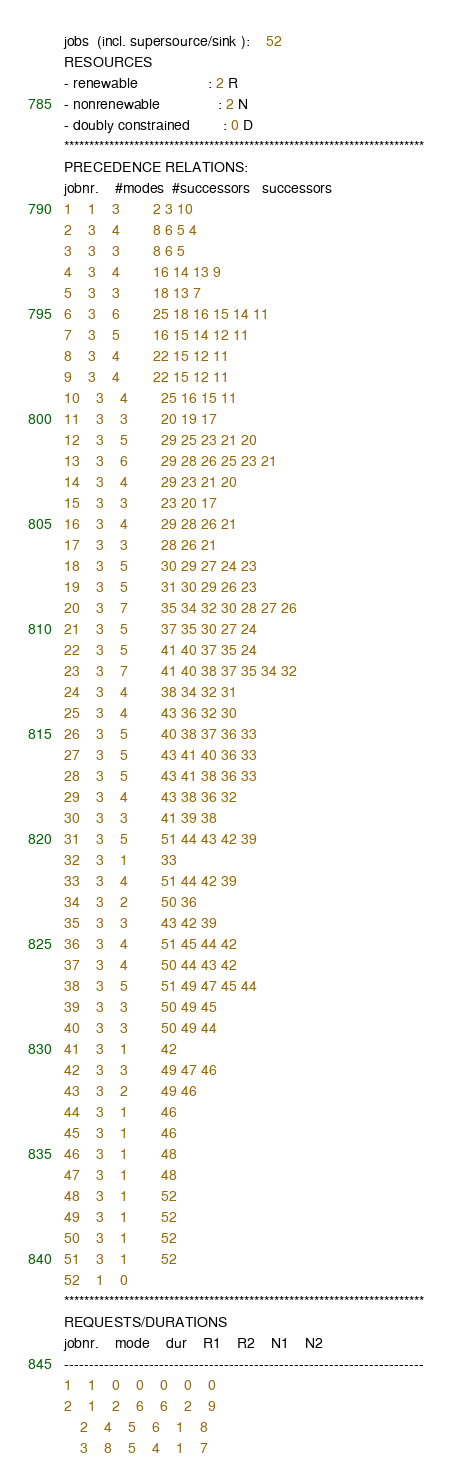<code> <loc_0><loc_0><loc_500><loc_500><_ObjectiveC_>jobs  (incl. supersource/sink ):	52
RESOURCES
- renewable                 : 2 R
- nonrenewable              : 2 N
- doubly constrained        : 0 D
************************************************************************
PRECEDENCE RELATIONS:
jobnr.    #modes  #successors   successors
1	1	3		2 3 10 
2	3	4		8 6 5 4 
3	3	3		8 6 5 
4	3	4		16 14 13 9 
5	3	3		18 13 7 
6	3	6		25 18 16 15 14 11 
7	3	5		16 15 14 12 11 
8	3	4		22 15 12 11 
9	3	4		22 15 12 11 
10	3	4		25 16 15 11 
11	3	3		20 19 17 
12	3	5		29 25 23 21 20 
13	3	6		29 28 26 25 23 21 
14	3	4		29 23 21 20 
15	3	3		23 20 17 
16	3	4		29 28 26 21 
17	3	3		28 26 21 
18	3	5		30 29 27 24 23 
19	3	5		31 30 29 26 23 
20	3	7		35 34 32 30 28 27 26 
21	3	5		37 35 30 27 24 
22	3	5		41 40 37 35 24 
23	3	7		41 40 38 37 35 34 32 
24	3	4		38 34 32 31 
25	3	4		43 36 32 30 
26	3	5		40 38 37 36 33 
27	3	5		43 41 40 36 33 
28	3	5		43 41 38 36 33 
29	3	4		43 38 36 32 
30	3	3		41 39 38 
31	3	5		51 44 43 42 39 
32	3	1		33 
33	3	4		51 44 42 39 
34	3	2		50 36 
35	3	3		43 42 39 
36	3	4		51 45 44 42 
37	3	4		50 44 43 42 
38	3	5		51 49 47 45 44 
39	3	3		50 49 45 
40	3	3		50 49 44 
41	3	1		42 
42	3	3		49 47 46 
43	3	2		49 46 
44	3	1		46 
45	3	1		46 
46	3	1		48 
47	3	1		48 
48	3	1		52 
49	3	1		52 
50	3	1		52 
51	3	1		52 
52	1	0		
************************************************************************
REQUESTS/DURATIONS
jobnr.	mode	dur	R1	R2	N1	N2	
------------------------------------------------------------------------
1	1	0	0	0	0	0	
2	1	2	6	6	2	9	
	2	4	5	6	1	8	
	3	8	5	4	1	7	</code> 